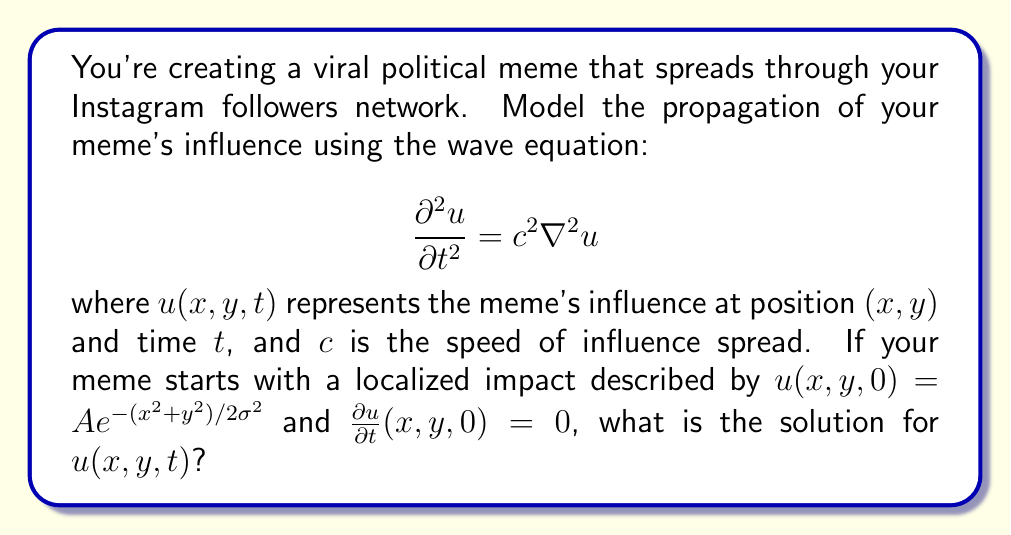Could you help me with this problem? To solve this problem, we need to use the method of separation of variables and the properties of Bessel functions. Here's a step-by-step approach:

1) The general solution for the 2D wave equation in polar coordinates is:

   $$u(r,\theta,t) = \int_0^\infty [A(k)\cos(ckt) + B(k)\sin(ckt)]J_0(kr)k\,dk$$

   where $J_0$ is the Bessel function of the first kind of order zero.

2) Given the initial conditions, we can see that $B(k) = 0$ (since $\frac{\partial u}{\partial t}(x,y,0) = 0$).

3) The initial condition $u(x,y,0) = Ae^{-(x^2+y^2)/2\sigma^2}$ can be rewritten in polar coordinates as:

   $$u(r,0) = Ae^{-r^2/2\sigma^2}$$

4) To find $A(k)$, we need to solve:

   $$Ae^{-r^2/2\sigma^2} = \int_0^\infty A(k)J_0(kr)k\,dk$$

5) This is a Hankel transform, and its solution is:

   $$A(k) = A\sigma^2 e^{-k^2\sigma^2/2}$$

6) Substituting this back into the general solution:

   $$u(r,t) = A\sigma^2 \int_0^\infty e^{-k^2\sigma^2/2}\cos(ckt)J_0(kr)k\,dk$$

7) This integral can be evaluated to give the final solution:

   $$u(r,t) = \frac{A\sigma^2}{\sigma^2 + c^2t^2} e^{-r^2/2(\sigma^2 + c^2t^2)}$$

8) Converting back to Cartesian coordinates:

   $$u(x,y,t) = \frac{A\sigma^2}{\sigma^2 + c^2t^2} e^{-(x^2+y^2)/2(\sigma^2 + c^2t^2)}$$

This solution represents a spreading Gaussian pulse, which models how your meme's influence spreads over time through your follower network.
Answer: $$u(x,y,t) = \frac{A\sigma^2}{\sigma^2 + c^2t^2} e^{-(x^2+y^2)/2(\sigma^2 + c^2t^2)}$$ 